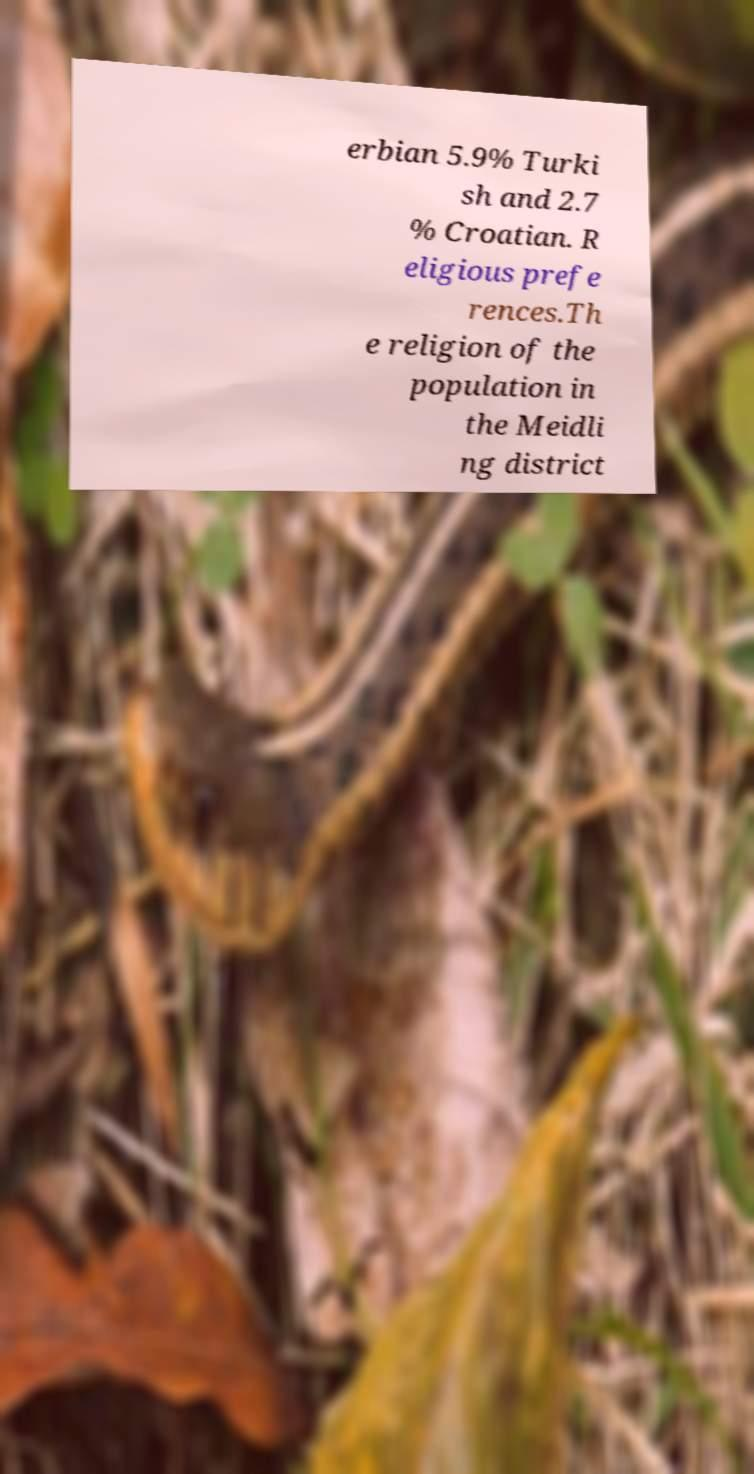Please identify and transcribe the text found in this image. erbian 5.9% Turki sh and 2.7 % Croatian. R eligious prefe rences.Th e religion of the population in the Meidli ng district 